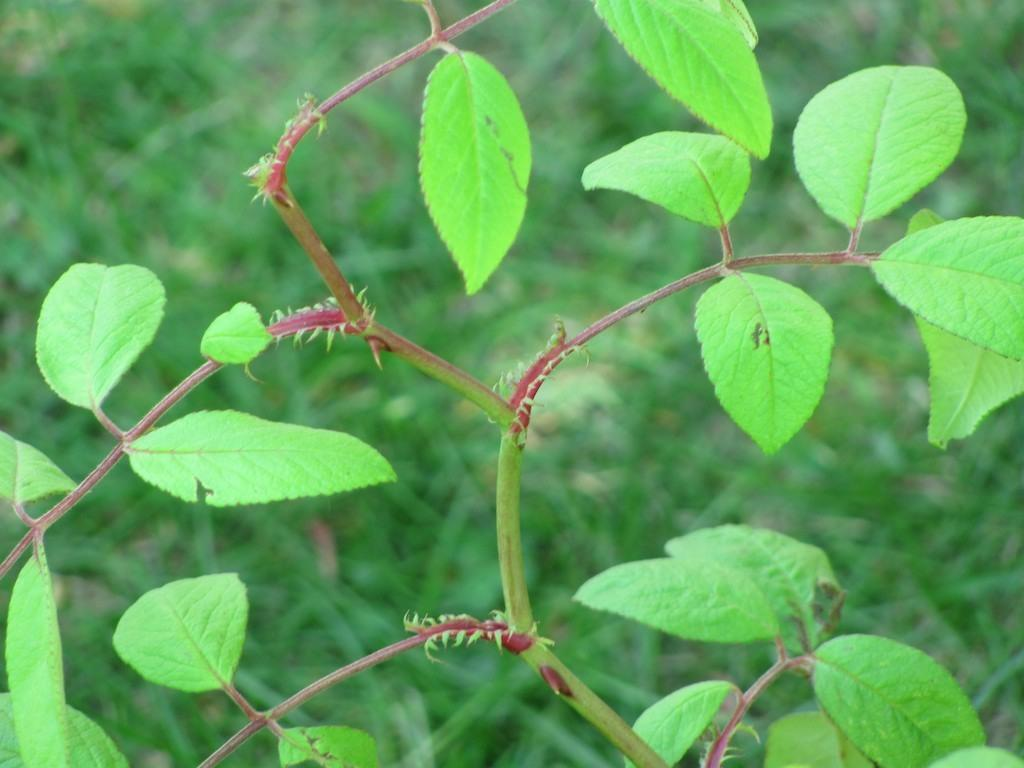What type of living organisms can be seen in the image? Plants can be seen in the image. What type of skirt is the family wearing in the image? There is no family or skirt present in the image; it only features plants. 